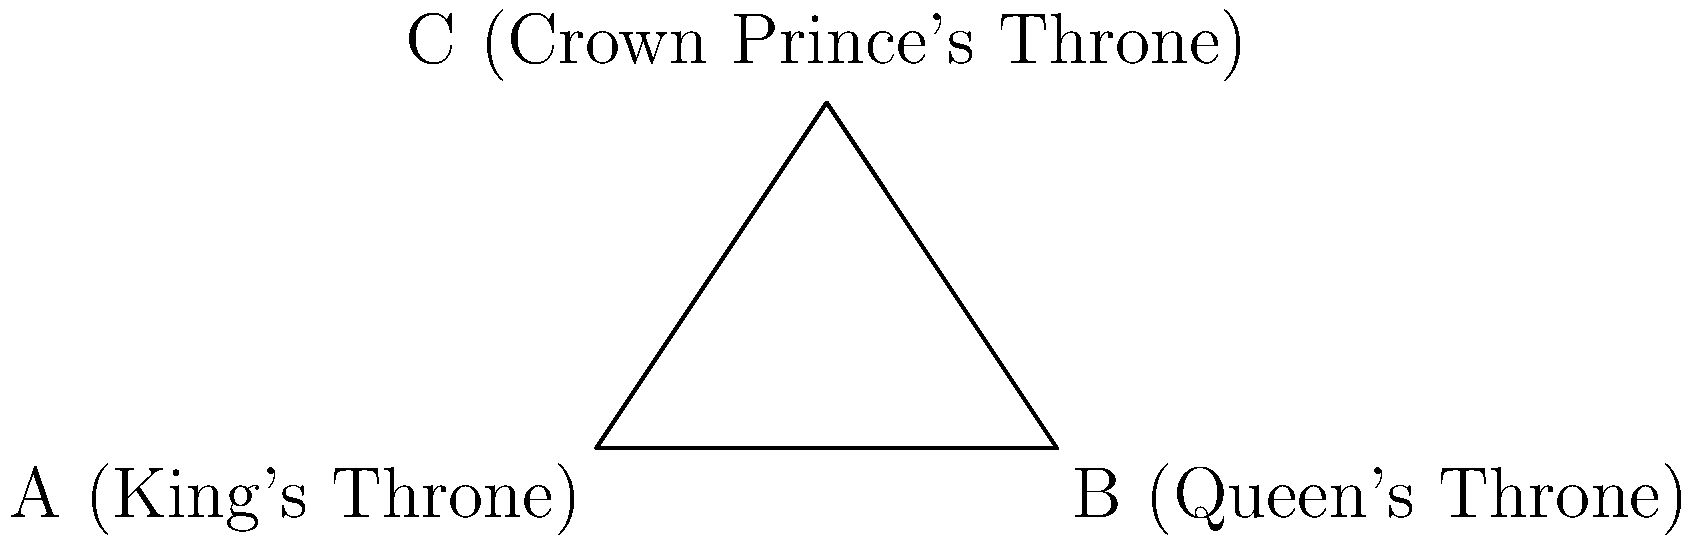In the Royal Hall of Stockholm Palace, the thrones are positioned to form a triangle. The angle between the King's and Queen's thrones is a right angle, and the angle at the Queen's throne is 30°. What is the measure of the angle $x°$ at the Crown Prince's throne? Let's approach this step-by-step:

1) In any triangle, the sum of all angles is 180°.

2) We are given that:
   - The angle at A (King's throne) is 90° (right angle)
   - The angle at B (Queen's throne) is 30°

3) Let's call the angle at C (Crown Prince's throne) $x°$.

4) We can set up an equation based on the fact that the sum of angles in a triangle is 180°:

   $90° + 30° + x° = 180°$

5) Simplifying:
   $120° + x° = 180°$

6) Subtracting 120° from both sides:
   $x° = 180° - 120° = 60°$

Therefore, the angle at the Crown Prince's throne is 60°.
Answer: 60° 